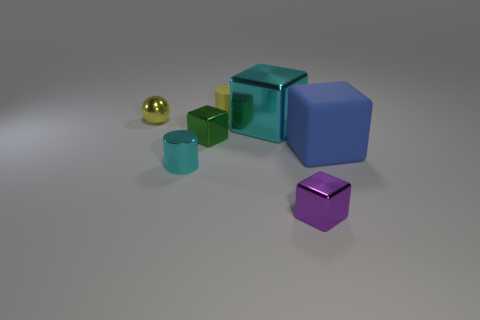Subtract all red cubes. Subtract all cyan balls. How many cubes are left? 4 Add 3 matte cylinders. How many objects exist? 10 Subtract all spheres. How many objects are left? 6 Subtract 0 blue cylinders. How many objects are left? 7 Subtract all tiny green shiny blocks. Subtract all big blue things. How many objects are left? 5 Add 1 cyan cubes. How many cyan cubes are left? 2 Add 3 tiny metal cylinders. How many tiny metal cylinders exist? 4 